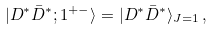<formula> <loc_0><loc_0><loc_500><loc_500>| D ^ { * } \bar { D } ^ { * } ; 1 ^ { + - } \rangle = | D ^ { * } \bar { D } ^ { * } \rangle _ { J = 1 } \, ,</formula> 